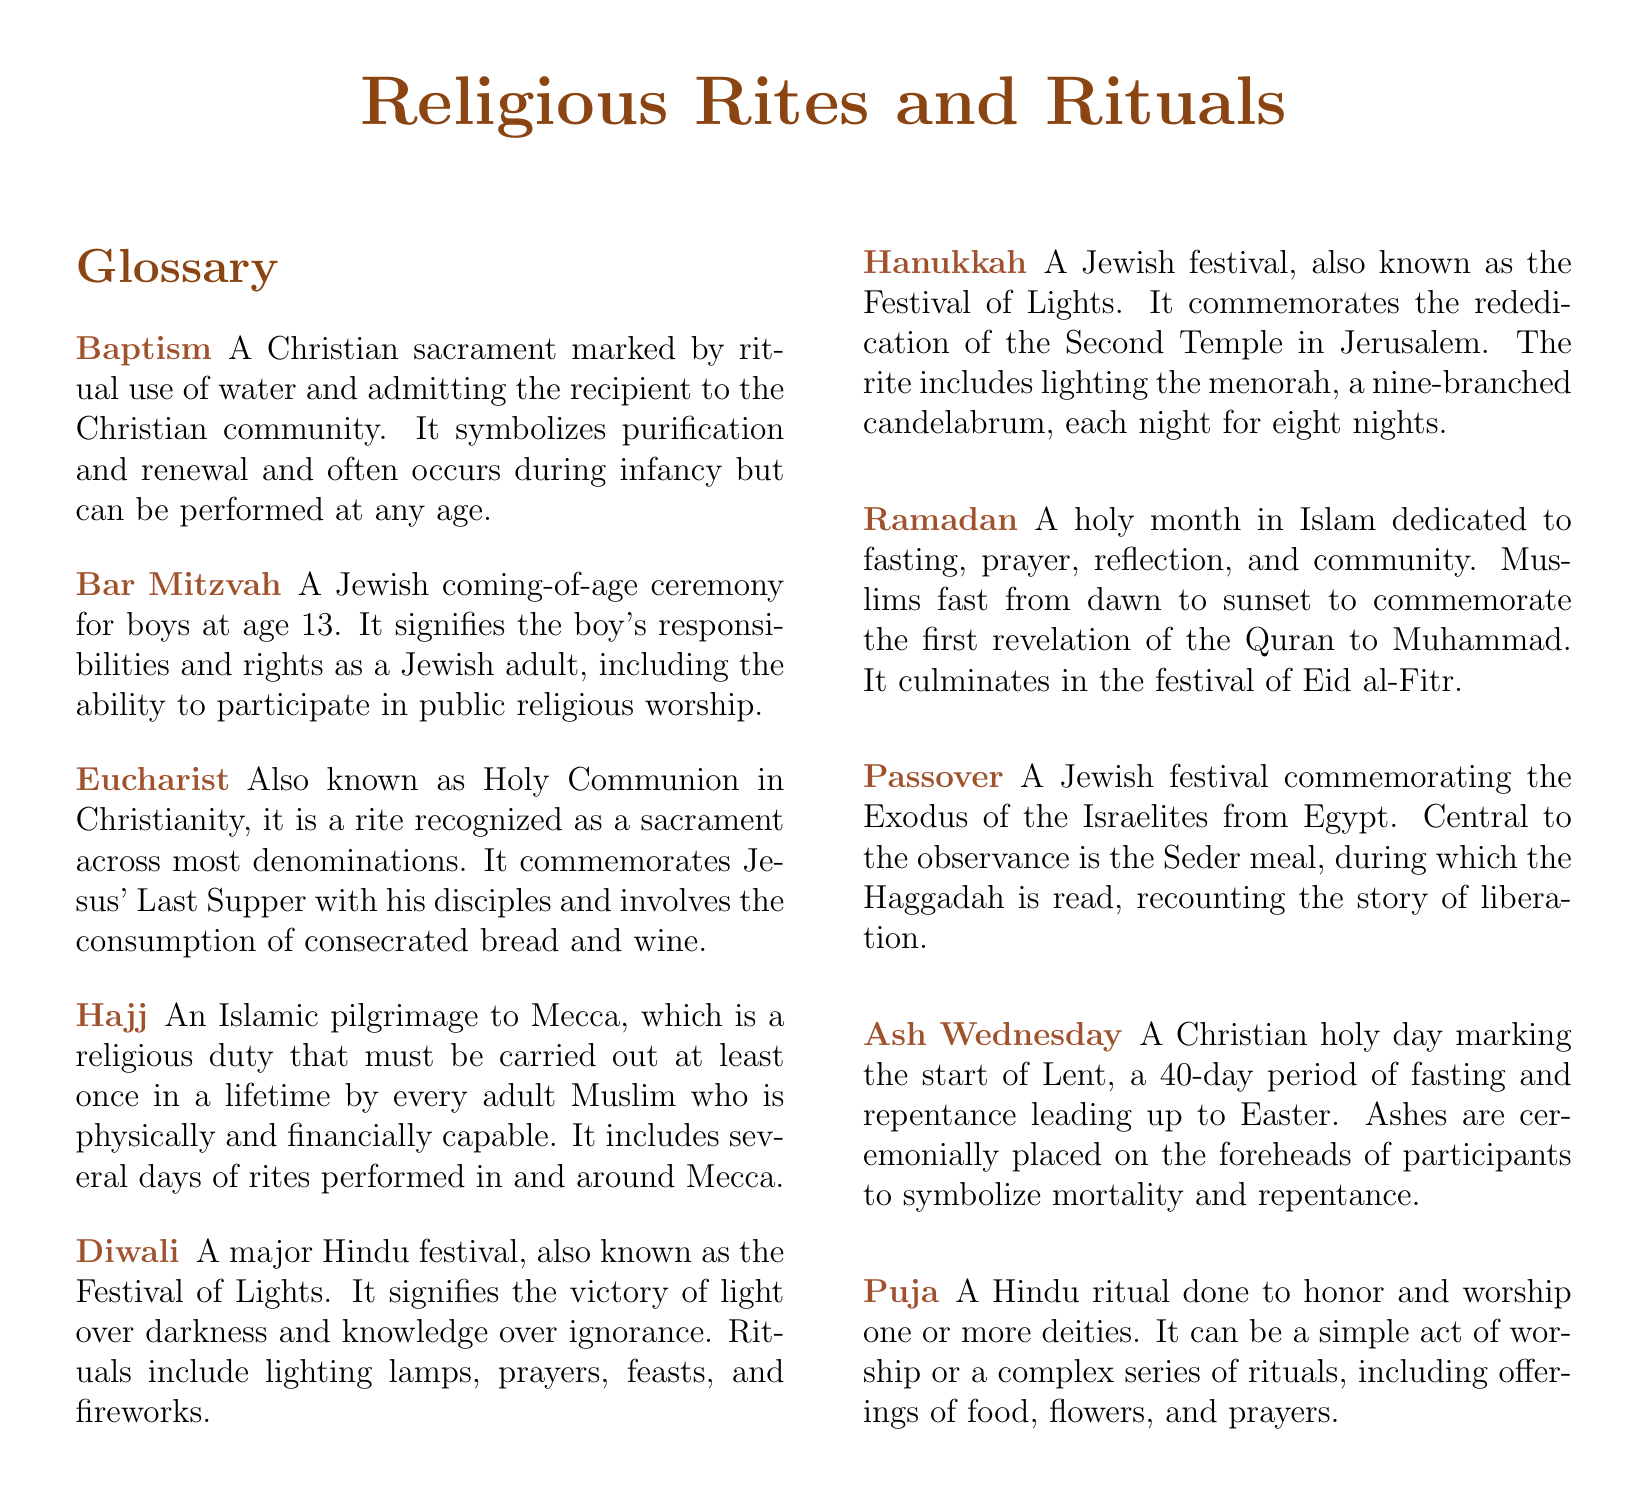What is the Christian sacrament marked by the ritual use of water? The glossary defines Baptism as a Christian sacrament marked by the ritual use of water.
Answer: Baptism What age is a boy expected to have his Bar Mitzvah? According to the document, the Bar Mitzvah ceremony occurs for boys at age 13.
Answer: 13 What is the Festival of Lights in Hinduism called? The document refers to Diwali as the major Hindu festival known as the Festival of Lights.
Answer: Diwali What key event does the Eucharist commemorate? The Eucharist commemorates Jesus' Last Supper with his disciples, as stated in the glossary.
Answer: Last Supper How long does Ramadan last? The document implies that Ramadan is a holy month, typically lasting 29-30 days.
Answer: 29-30 days What ritual is performed during Ash Wednesday? The glossary indicates that ashes are ceremonially placed on the foreheads of participants during Ash Wednesday.
Answer: Ashes on foreheads Which Jewish festival includes the lighting of a menorah? The document specifies that Hanukkah involves lighting the menorah each night for eight nights.
Answer: Hanukkah What is the Seder meal associated with? The glossary states that the Seder meal is central to the observance of Passover.
Answer: Passover What does Hajj represent in Islam? The glossary defines Hajj as a religious duty that must be carried out at least once in a lifetime by every adult Muslim.
Answer: Religious duty 